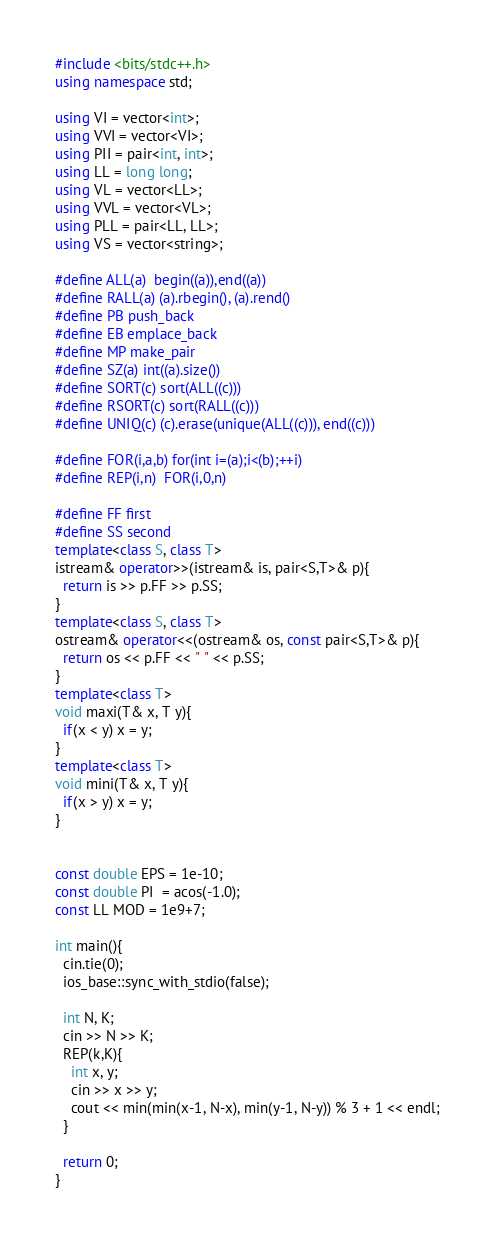<code> <loc_0><loc_0><loc_500><loc_500><_C++_>#include <bits/stdc++.h>
using namespace std;

using VI = vector<int>;
using VVI = vector<VI>;
using PII = pair<int, int>;
using LL = long long;
using VL = vector<LL>;
using VVL = vector<VL>;
using PLL = pair<LL, LL>;
using VS = vector<string>;

#define ALL(a)  begin((a)),end((a))
#define RALL(a) (a).rbegin(), (a).rend()
#define PB push_back
#define EB emplace_back
#define MP make_pair
#define SZ(a) int((a).size())
#define SORT(c) sort(ALL((c)))
#define RSORT(c) sort(RALL((c)))
#define UNIQ(c) (c).erase(unique(ALL((c))), end((c)))

#define FOR(i,a,b) for(int i=(a);i<(b);++i)
#define REP(i,n)  FOR(i,0,n)

#define FF first
#define SS second
template<class S, class T>
istream& operator>>(istream& is, pair<S,T>& p){
  return is >> p.FF >> p.SS;
}
template<class S, class T>
ostream& operator<<(ostream& os, const pair<S,T>& p){
  return os << p.FF << " " << p.SS;
}
template<class T>
void maxi(T& x, T y){
  if(x < y) x = y;
}
template<class T>
void mini(T& x, T y){
  if(x > y) x = y;
}


const double EPS = 1e-10;
const double PI  = acos(-1.0);
const LL MOD = 1e9+7;

int main(){
  cin.tie(0);
  ios_base::sync_with_stdio(false);

  int N, K;
  cin >> N >> K;
  REP(k,K){
	int x, y;
	cin >> x >> y;
	cout << min(min(x-1, N-x), min(y-1, N-y)) % 3 + 1 << endl;
  }

  return 0;
}</code> 